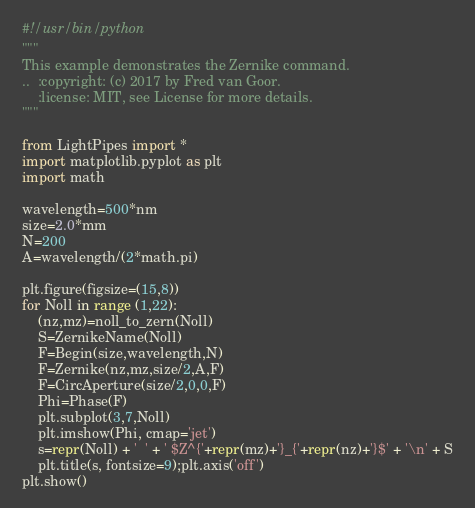<code> <loc_0><loc_0><loc_500><loc_500><_Python_>#!/usr/bin/python
"""
This example demonstrates the Zernike command.
..  :copyright: (c) 2017 by Fred van Goor.
    :license: MIT, see License for more details.
"""

from LightPipes import *
import matplotlib.pyplot as plt
import math

wavelength=500*nm
size=2.0*mm
N=200
A=wavelength/(2*math.pi)

plt.figure(figsize=(15,8)) 
for Noll in range (1,22):
    (nz,mz)=noll_to_zern(Noll)
    S=ZernikeName(Noll)
    F=Begin(size,wavelength,N)
    F=Zernike(nz,mz,size/2,A,F)
    F=CircAperture(size/2,0,0,F)
    Phi=Phase(F)
    plt.subplot(3,7,Noll)
    plt.imshow(Phi, cmap='jet')
    s=repr(Noll) + '  ' + ' $Z^{'+repr(mz)+'}_{'+repr(nz)+'}$' + '\n' + S
    plt.title(s, fontsize=9);plt.axis('off')
plt.show()

</code> 